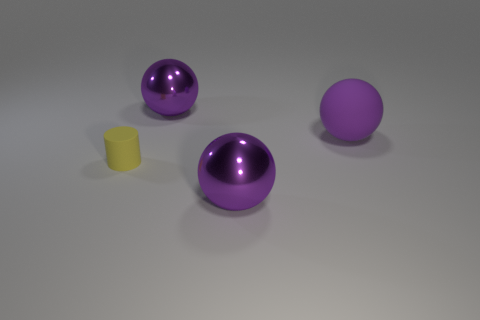Is there anything else that is the same size as the yellow matte object?
Keep it short and to the point. No. Are there any other things that have the same shape as the small thing?
Ensure brevity in your answer.  No. How many purple shiny things are behind the rubber object right of the big metal object in front of the big matte sphere?
Your response must be concise. 1. Are there any small cylinders to the left of the yellow rubber cylinder?
Offer a terse response. No. What number of tiny yellow things are the same material as the small yellow cylinder?
Ensure brevity in your answer.  0. What number of objects are yellow rubber things or large matte balls?
Your answer should be very brief. 2. Is there a big gray shiny ball?
Your answer should be very brief. No. The purple sphere right of the metal sphere in front of the big purple metallic sphere that is behind the yellow rubber thing is made of what material?
Provide a short and direct response. Rubber. Are there fewer yellow matte things in front of the cylinder than purple spheres?
Your response must be concise. Yes. There is a object that is both in front of the purple matte object and to the right of the yellow rubber cylinder; what is its size?
Keep it short and to the point. Large. 